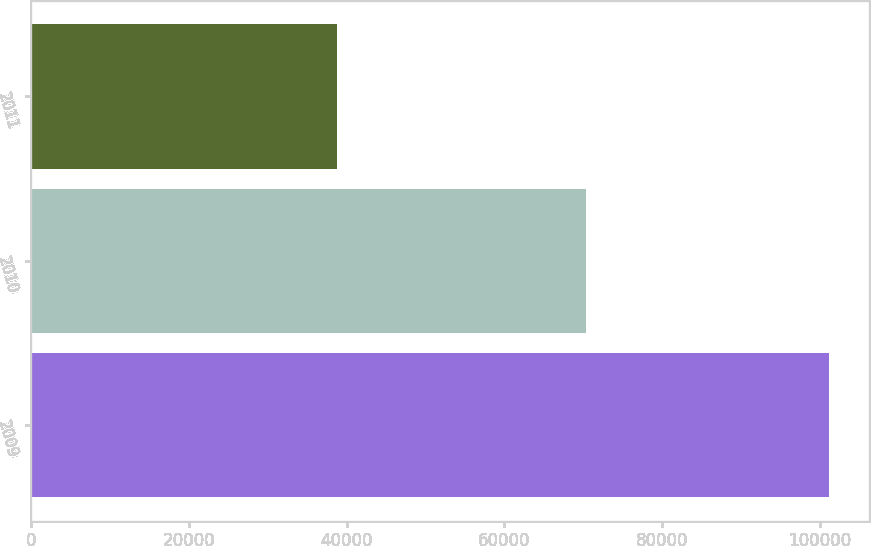Convert chart to OTSL. <chart><loc_0><loc_0><loc_500><loc_500><bar_chart><fcel>2009<fcel>2010<fcel>2011<nl><fcel>101180<fcel>70298<fcel>38765<nl></chart> 